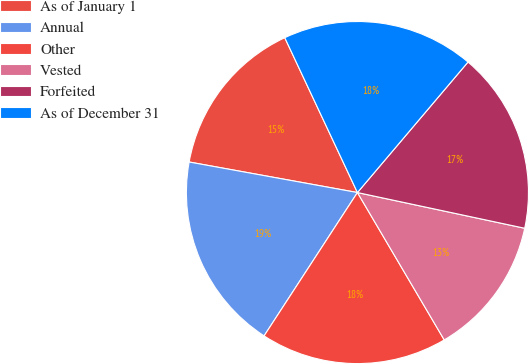<chart> <loc_0><loc_0><loc_500><loc_500><pie_chart><fcel>As of January 1<fcel>Annual<fcel>Other<fcel>Vested<fcel>Forfeited<fcel>As of December 31<nl><fcel>15.16%<fcel>18.67%<fcel>17.66%<fcel>13.18%<fcel>17.16%<fcel>18.17%<nl></chart> 